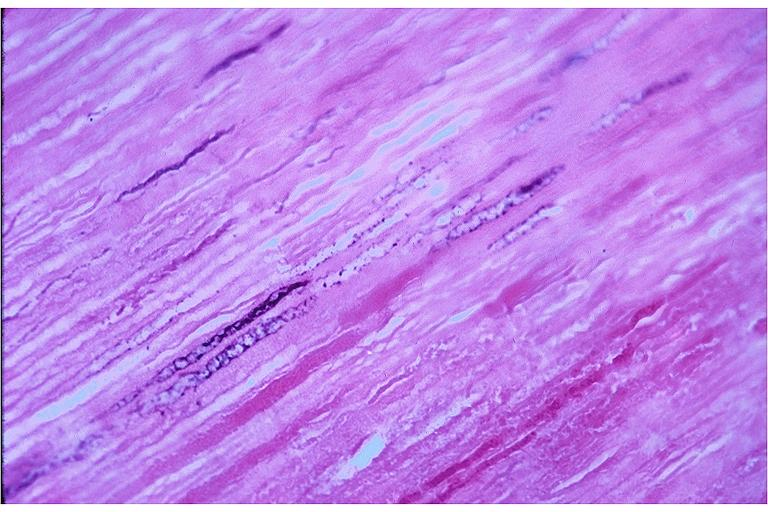what is present?
Answer the question using a single word or phrase. Oral 